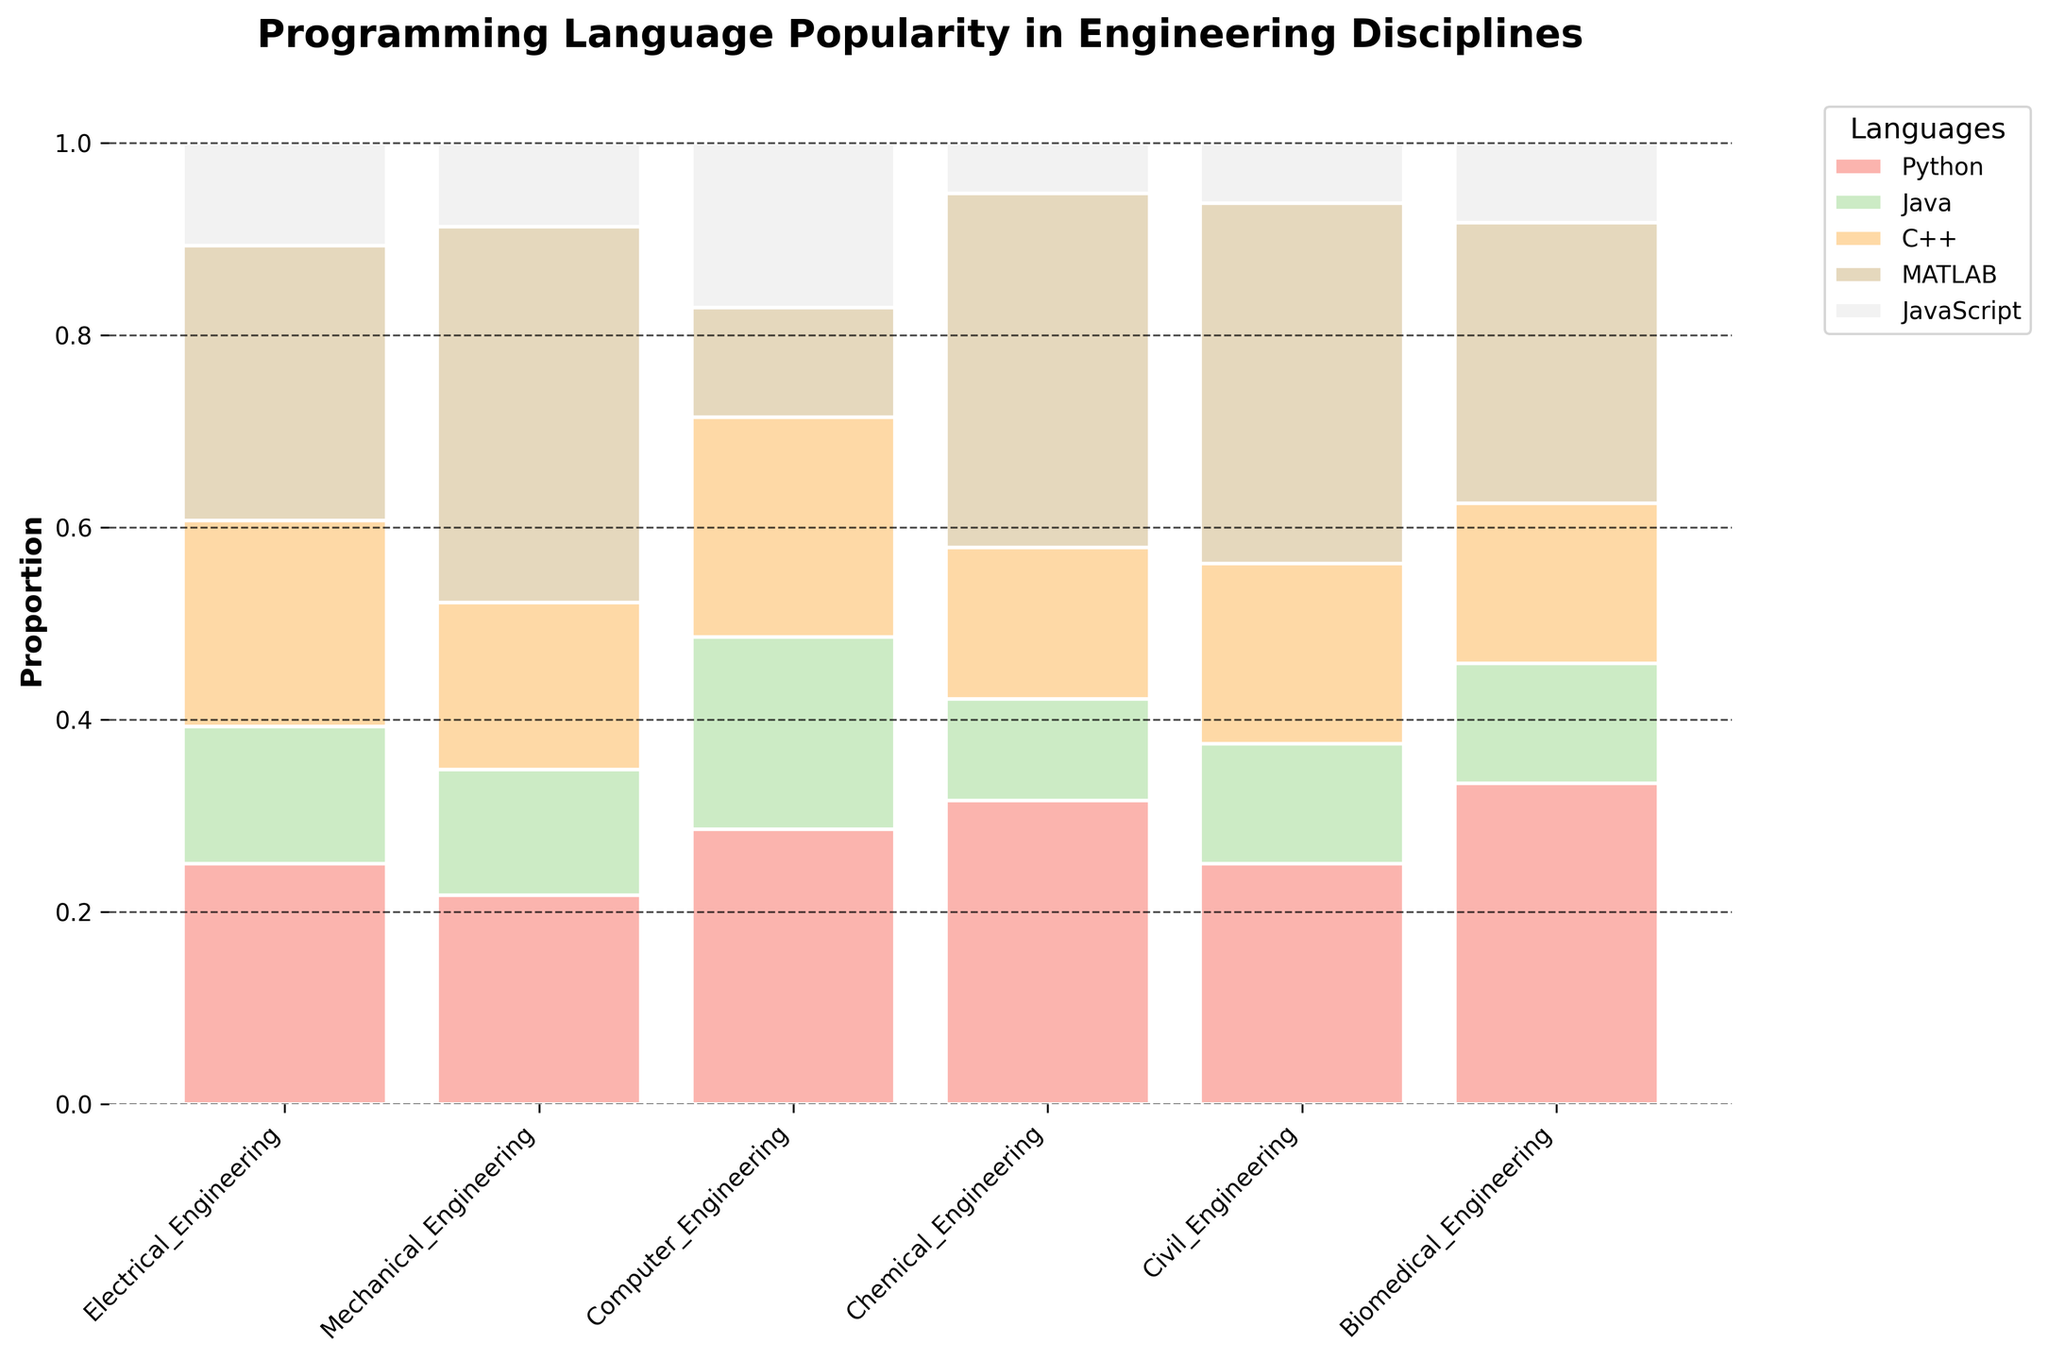What is the highest programming language proportion in Mechanical Engineering? Look at the bar corresponding to Mechanical Engineering. The tallest segment in the bar represents MATLAB.
Answer: MATLAB Which discipline has the highest proportion of Python usage? Look at each discipline and compare the height of the Python segment. Computer Engineering has the tallest Python segment.
Answer: Computer Engineering Among Computer Engineering and Electrical Engineering, which discipline has the greater proportion of Java usage? Compare the height of the Java segment for both disciplines. Computer Engineering has a taller Java segment than Electrical Engineering.
Answer: Computer Engineering What is the approximate proportion of C++ usage in Civil Engineering? Look at the C++ segment in the Civil Engineering bar. The C++ segment occupies about a quarter of the bar.
Answer: ~25% Which language is least popular across all disciplines? Compare the heights of each language segment across all disciplines to determine which one has the smallest sections. JavaScript has the smallest overall sections.
Answer: JavaScript What's the proportion of MATLAB usage in Biomedical Engineering relative to Python usage in the same discipline? The height of the MATLAB segment in Biomedical Engineering is compared to the height of the Python segment. MATLAB's segment is slightly lower than Python's.
Answer: Less Compare the total proportion of programming languages used in Electrical Engineering and Chemical Engineering combined. Sum the heights of all segments for Electrical Engineering and Chemical Engineering. Electrical Engineering has a total height of 1 and Chemical Engineering also has a total height of 1.
Answer: Equal Which discipline has the most balanced proportions of language usage? Look for the discipline where the different colored segments in its bar are most similar in height. Biomedical Engineering appears most balanced.
Answer: Biomedical Engineering 